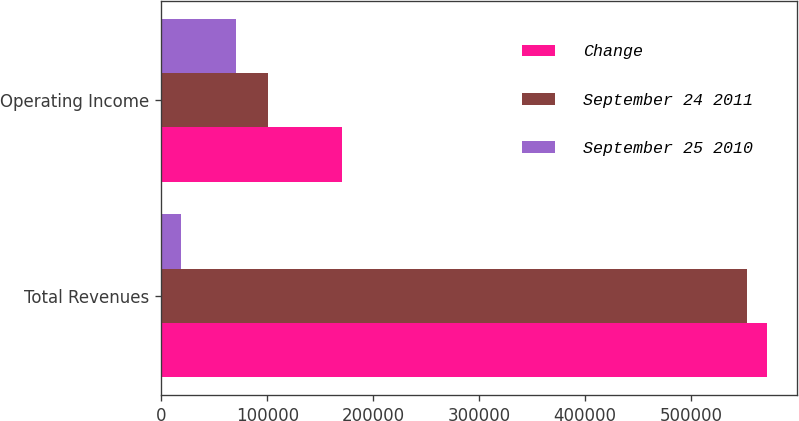Convert chart. <chart><loc_0><loc_0><loc_500><loc_500><stacked_bar_chart><ecel><fcel>Total Revenues<fcel>Operating Income<nl><fcel>Change<fcel>571263<fcel>170693<nl><fcel>September 24 2011<fcel>552501<fcel>100469<nl><fcel>September 25 2010<fcel>18762<fcel>70224<nl></chart> 